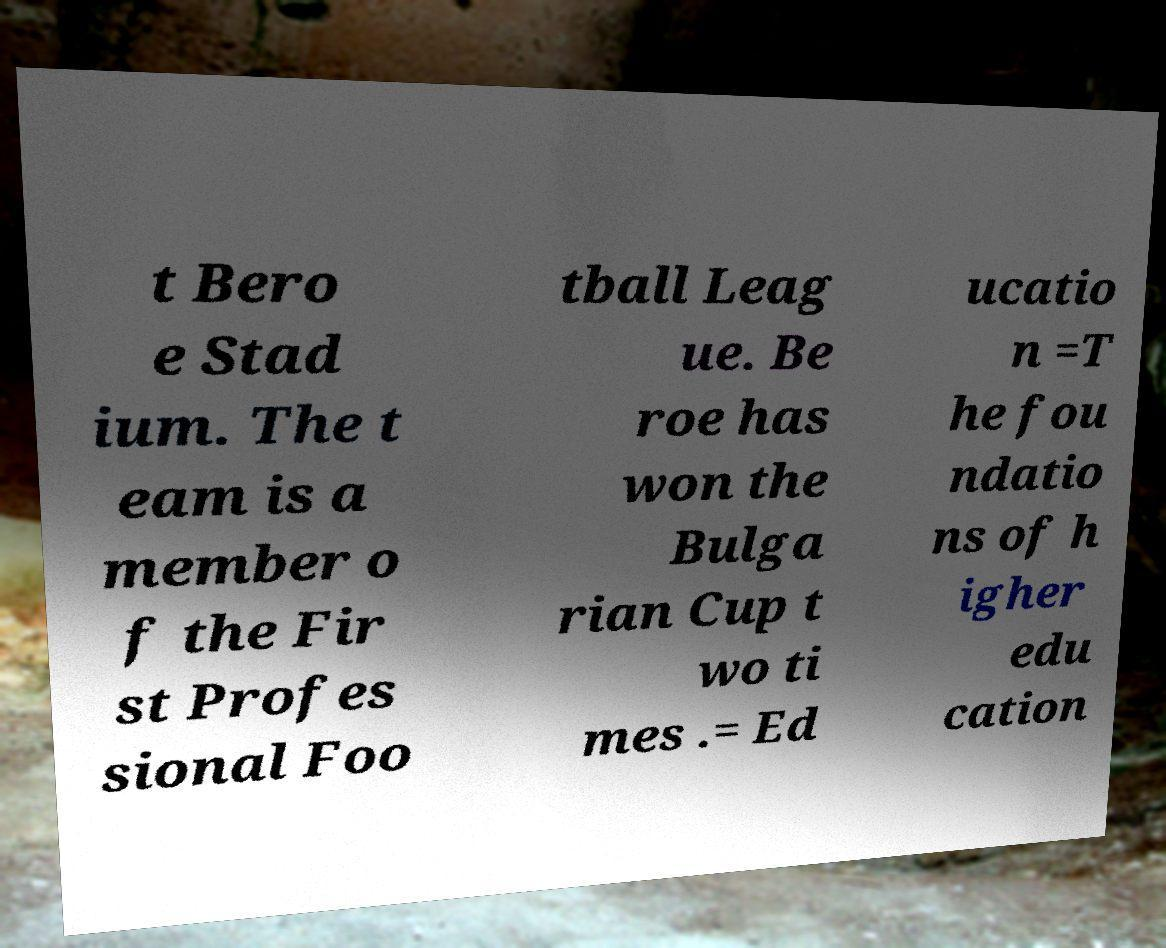Can you read and provide the text displayed in the image?This photo seems to have some interesting text. Can you extract and type it out for me? t Bero e Stad ium. The t eam is a member o f the Fir st Profes sional Foo tball Leag ue. Be roe has won the Bulga rian Cup t wo ti mes .= Ed ucatio n =T he fou ndatio ns of h igher edu cation 